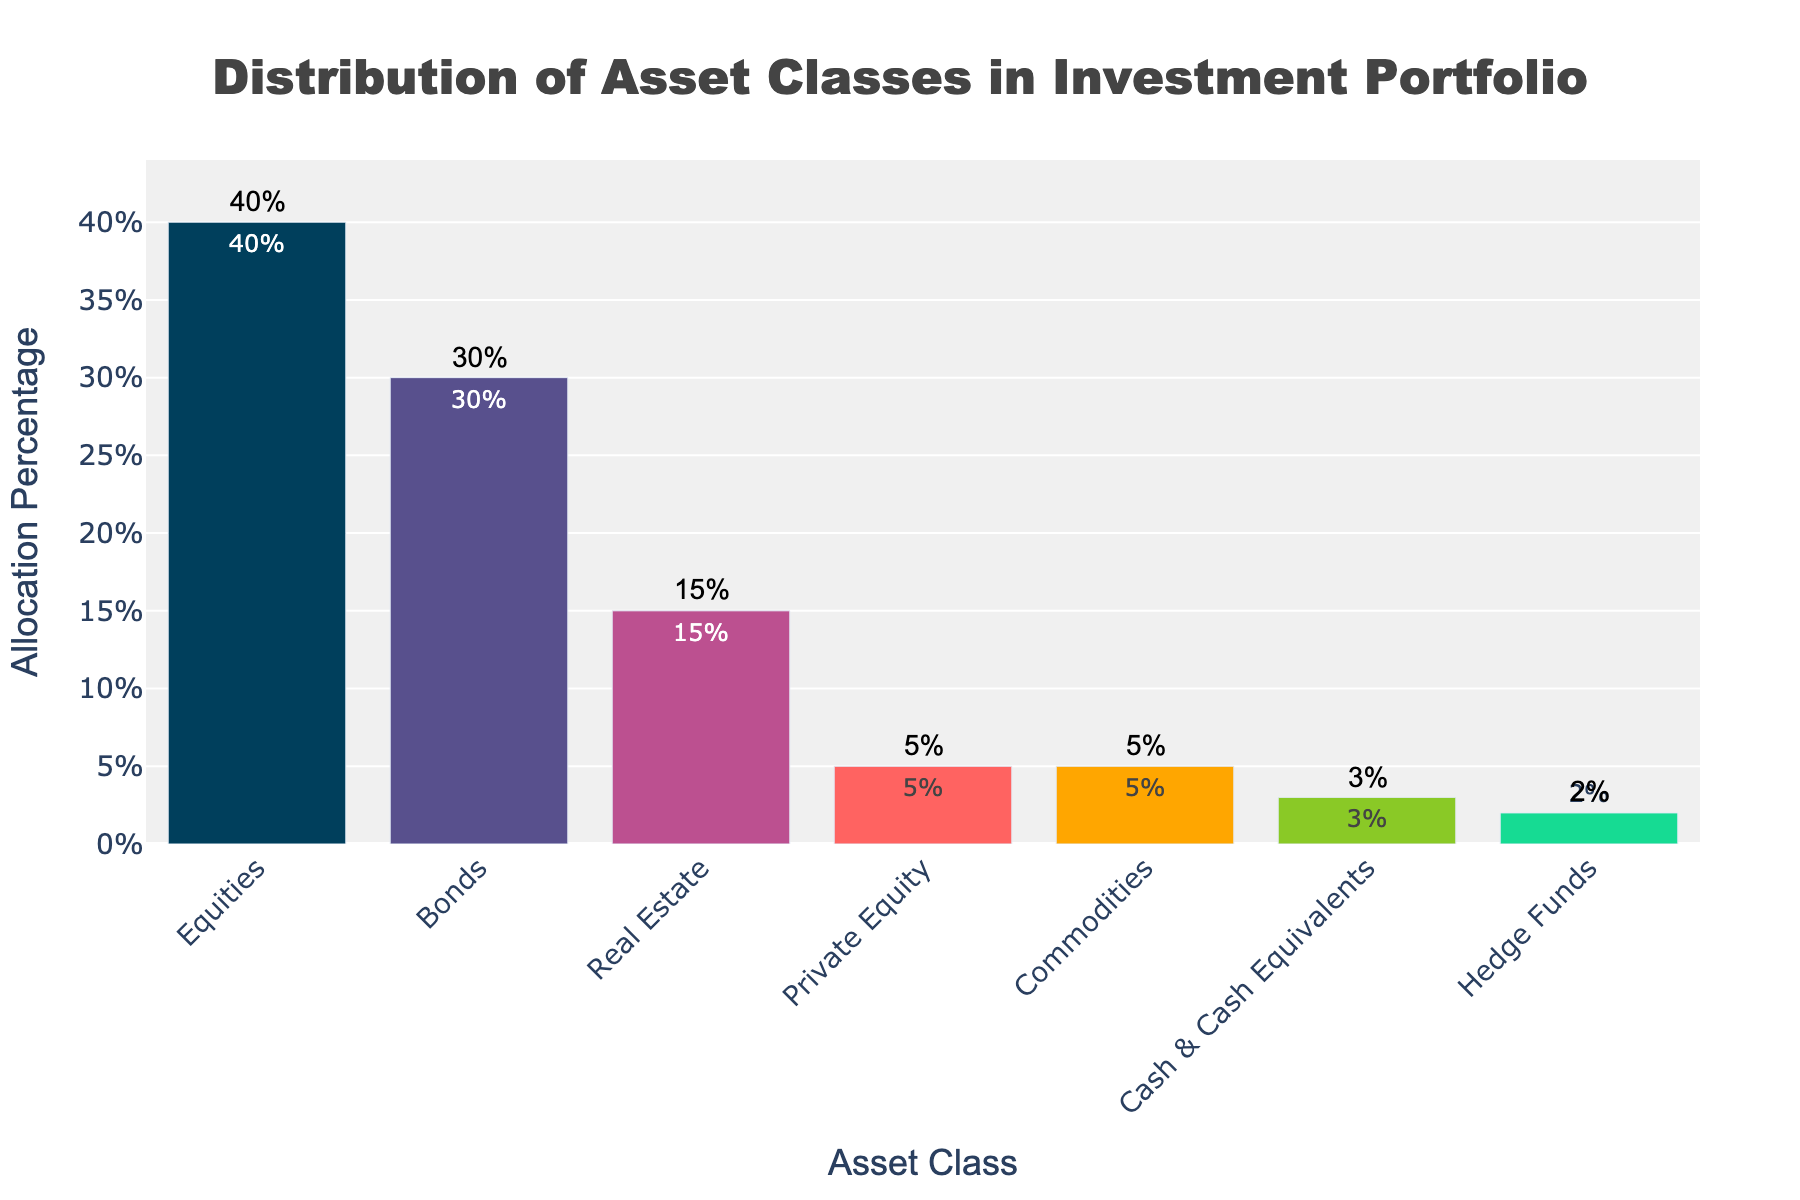What's the title of the figure? The title is often located at the top of a figure and is larger and bolder than other text. Here, it reads 'Distribution of Asset Classes in Investment Portfolio'.
Answer: Distribution of Asset Classes in Investment Portfolio What is the asset class with the highest allocation percentage? The tallest bar in the bar plot represents the asset class with the highest allocation percentage. It is labeled with both the asset class name and the percentage. The highest bar corresponds to Equities with 40%.
Answer: Equities What is the combined allocation percentage for Real Estate and Private Equity? Adding the percentages of Real Estate (15%) and Private Equity (5%), the sum is 15% + 5% = 20%.
Answer: 20% Which asset class has the smallest allocation percentage and what is it? The shortest bar in the bar plot indicates the smallest allocation percentage, which is also labeled. Hedge Funds have the smallest allocation at 2%.
Answer: Hedge Funds, 2% How much higher is the allocation percentage of Bonds compared to Cash & Cash Equivalents? Subtracting the allocation percentage of Cash & Cash Equivalents (3%) from that of Bonds (30%) gives 30% - 3% = 27%.
Answer: 27% What are the colors used for the bars representing Equities and Real Estate? The colors of the bars can be identified by looking at the corresponding bars. Equities is represented in dark blue (#003f5c) and Real Estate in orange (#ff6361).
Answer: Dark blue and orange What is the combined allocation percentage of all asset classes excluding Equities and Bonds? Summing the allocation percentages of all asset classes except Equities (40%) and Bonds (30%): 15% + 5% + 5% + 3% + 2% = 30%.
Answer: 30% Which asset classes have an allocation percentage greater than 10% but less than 40%? Scanning the heights of the bars and their labels, Bonds (30%) and Real Estate (15%) both fall within this range.
Answer: Bonds and Real Estate What is the average allocation percentage of all asset classes listed? Adding all percentages: 40% + 30% + 15% + 5% + 5% + 3% + 2% = 100%. Dividing by the number of asset classes (7) gives 100% / 7 ≈ 14.29%.
Answer: 14.29% How many asset classes are represented in the figure? Counting the bars shown in the bar plot indicates the number of asset classes. There are 7 asset classes represented.
Answer: 7 